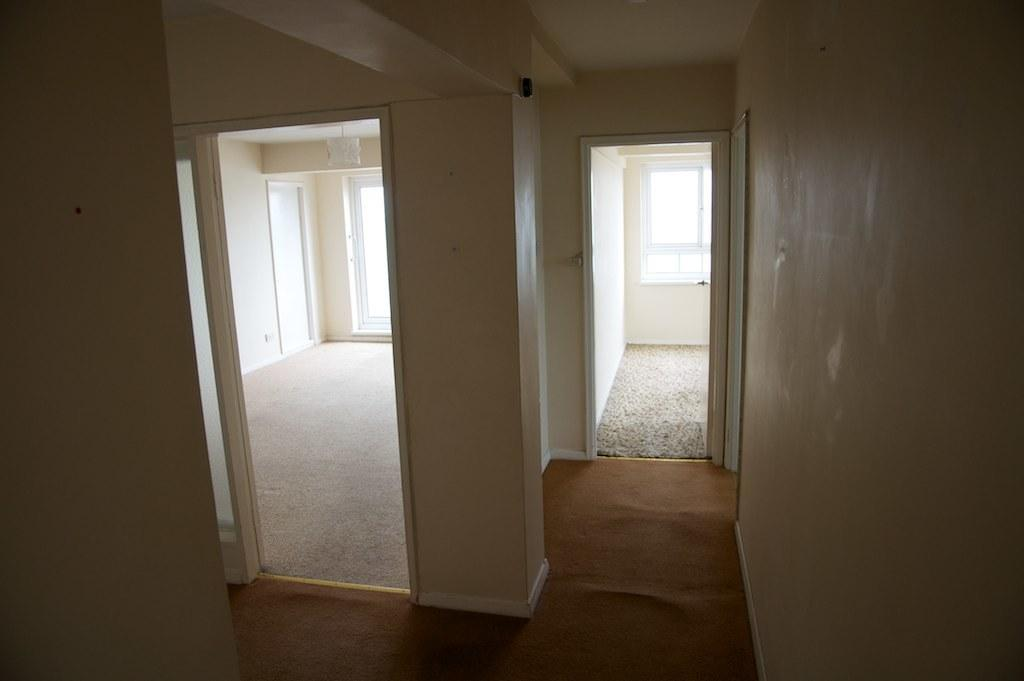What type of view is depicted in the image? The image shows an inner view of a building. What note is being played by the person coughing in the image? There is no person coughing or playing a note in the image, as it only shows an inner view of a building. 